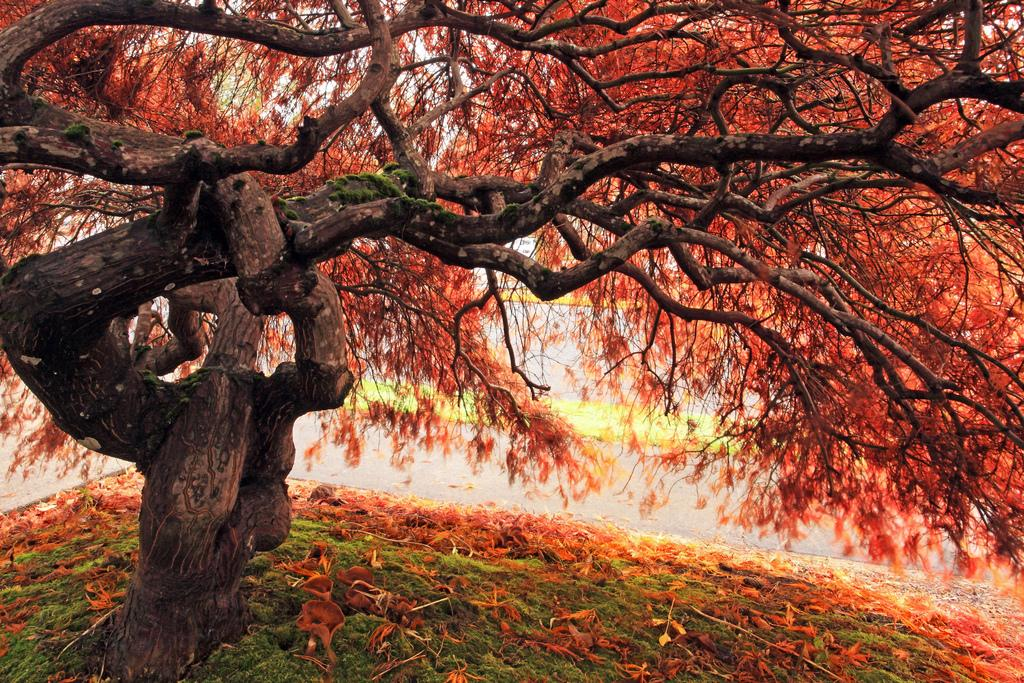What type of plant can be seen in the image? There is a tree in the image. What natural element is visible in the image? There is water visible in the image. What type of flora is present in the image? There are flowers in the image. What type of vegetation covers the ground in the image? There is grass on the ground in the image. Can you see a footprint in the grass in the image? There is no mention of footprints or a foot in the image, so we cannot determine if there is a footprint in the grass. 